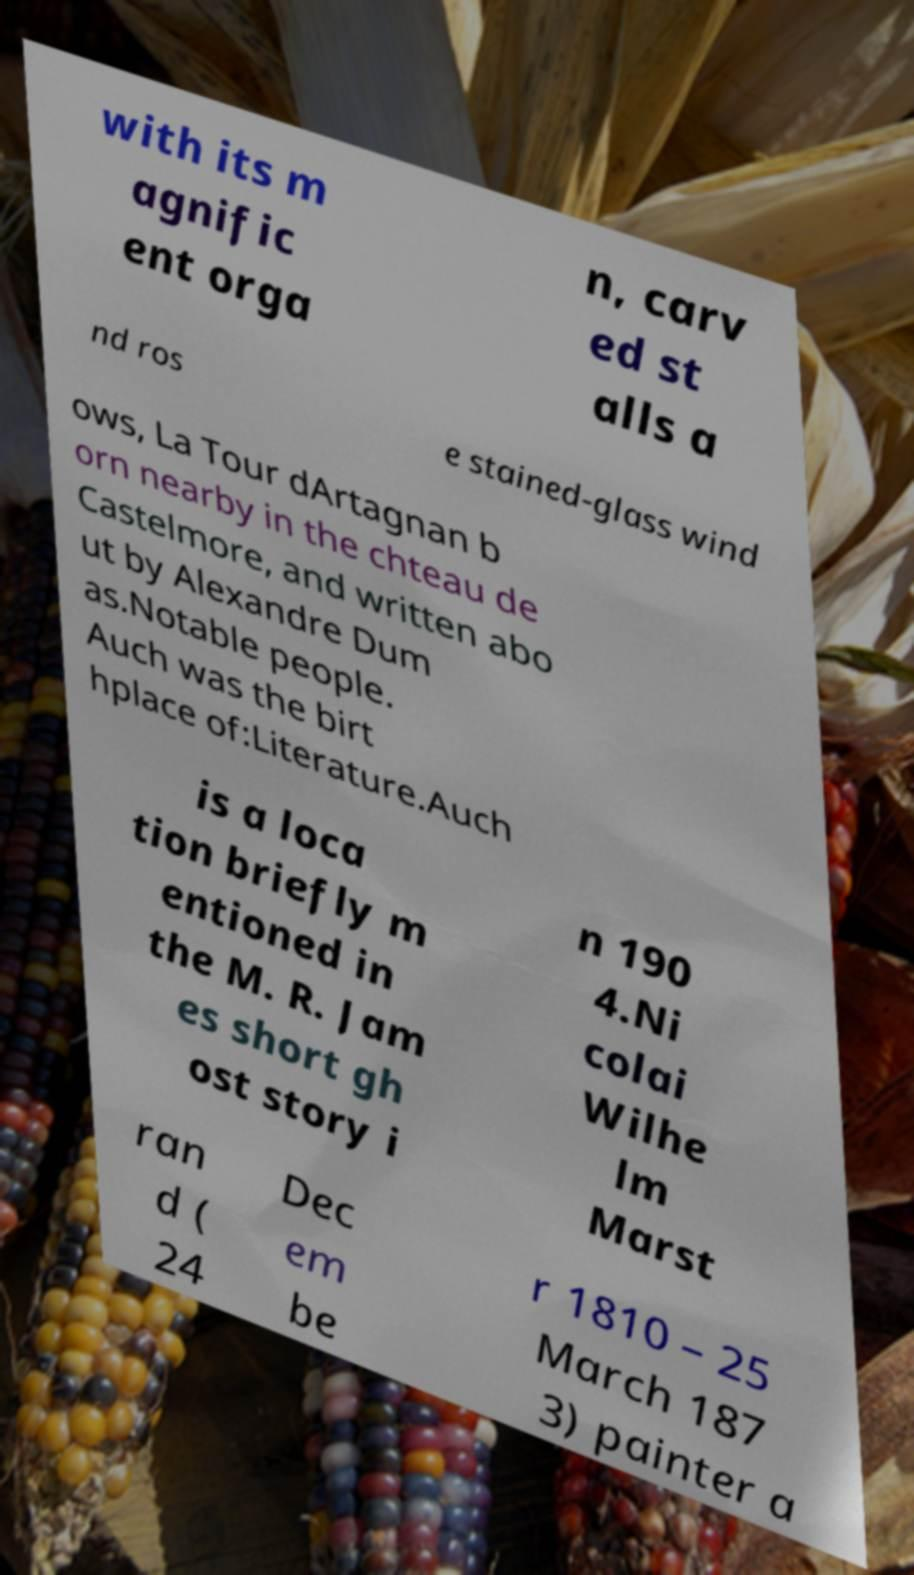For documentation purposes, I need the text within this image transcribed. Could you provide that? with its m agnific ent orga n, carv ed st alls a nd ros e stained-glass wind ows, La Tour dArtagnan b orn nearby in the chteau de Castelmore, and written abo ut by Alexandre Dum as.Notable people. Auch was the birt hplace of:Literature.Auch is a loca tion briefly m entioned in the M. R. Jam es short gh ost story i n 190 4.Ni colai Wilhe lm Marst ran d ( 24 Dec em be r 1810 – 25 March 187 3) painter a 